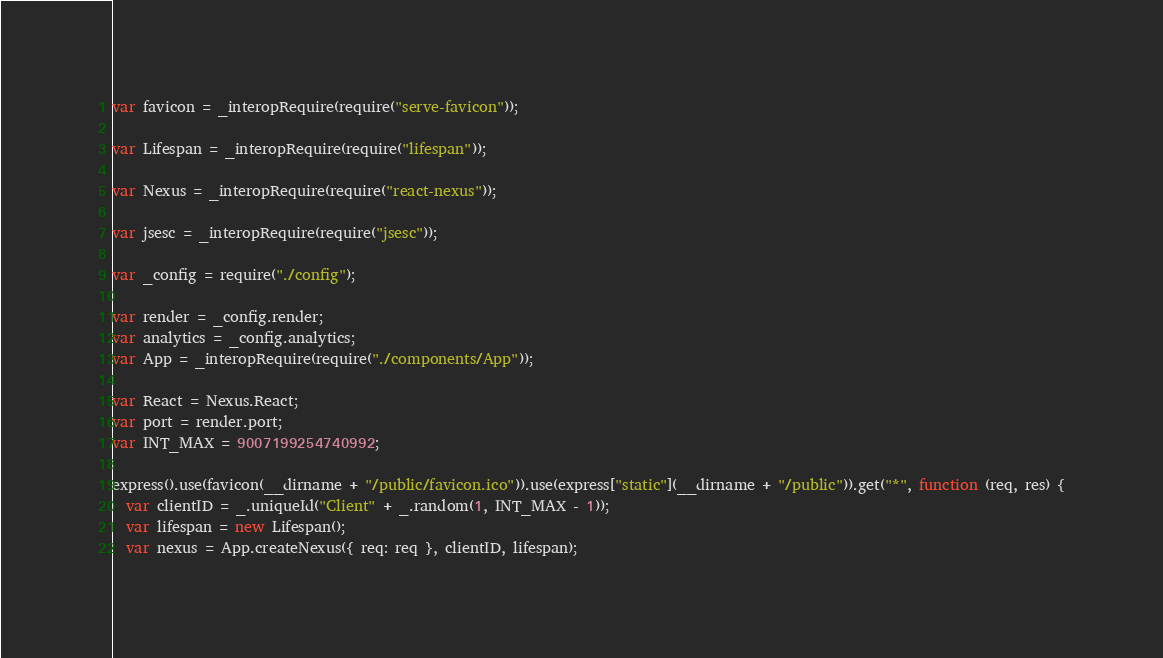<code> <loc_0><loc_0><loc_500><loc_500><_JavaScript_>
var favicon = _interopRequire(require("serve-favicon"));

var Lifespan = _interopRequire(require("lifespan"));

var Nexus = _interopRequire(require("react-nexus"));

var jsesc = _interopRequire(require("jsesc"));

var _config = require("./config");

var render = _config.render;
var analytics = _config.analytics;
var App = _interopRequire(require("./components/App"));

var React = Nexus.React;
var port = render.port;
var INT_MAX = 9007199254740992;

express().use(favicon(__dirname + "/public/favicon.ico")).use(express["static"](__dirname + "/public")).get("*", function (req, res) {
  var clientID = _.uniqueId("Client" + _.random(1, INT_MAX - 1));
  var lifespan = new Lifespan();
  var nexus = App.createNexus({ req: req }, clientID, lifespan);</code> 